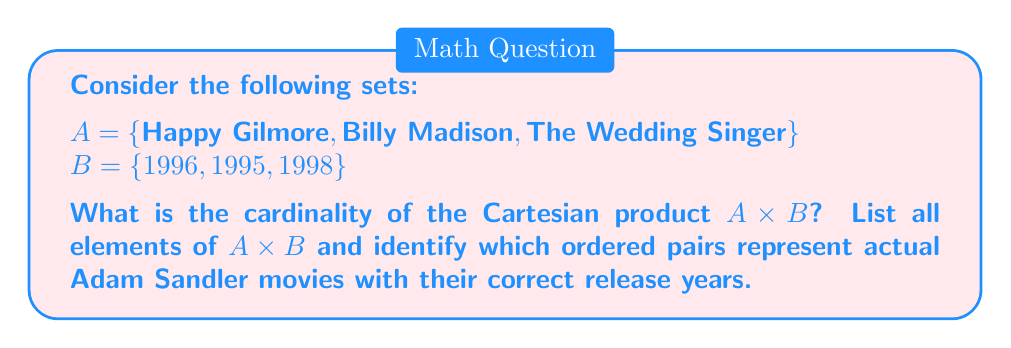Could you help me with this problem? To solve this problem, let's follow these steps:

1. Define the Cartesian product:
   The Cartesian product A × B is the set of all ordered pairs (a, b) where a ∈ A and b ∈ B.

2. Calculate the cardinality:
   The cardinality of A × B is given by |A × B| = |A| × |B|
   |A| = 3 and |B| = 3
   Therefore, |A × B| = 3 × 3 = 9

3. List all elements of A × B:
   A × B = {
   (Happy Gilmore, 1996), (Happy Gilmore, 1995), (Happy Gilmore, 1998),
   (Billy Madison, 1996), (Billy Madison, 1995), (Billy Madison, 1998),
   (The Wedding Singer, 1996), (The Wedding Singer, 1995), (The Wedding Singer, 1998)
   }

4. Identify correct movie-year pairs:
   - (Happy Gilmore, 1996) is correct
   - (Billy Madison, 1995) is correct
   - (The Wedding Singer, 1998) is correct

The Cartesian product contains all possible combinations, including those that don't represent actual movie-year pairs. This demonstrates how set theory can be applied to analyze relationships between films and their release years, which could be useful in studying filmography patterns or creating movie databases.
Answer: The cardinality of A × B is 9. The Cartesian product A × B contains 9 ordered pairs, of which 3 represent actual Adam Sandler movies with their correct release years: (Happy Gilmore, 1996), (Billy Madison, 1995), and (The Wedding Singer, 1998). 